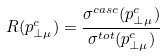<formula> <loc_0><loc_0><loc_500><loc_500>R ( p _ { \bot \mu } ^ { c } ) = \frac { \sigma ^ { c a s c } ( p _ { \bot \mu } ^ { c } ) } { \sigma ^ { t o t } ( p _ { \bot \mu } ^ { c } ) }</formula> 